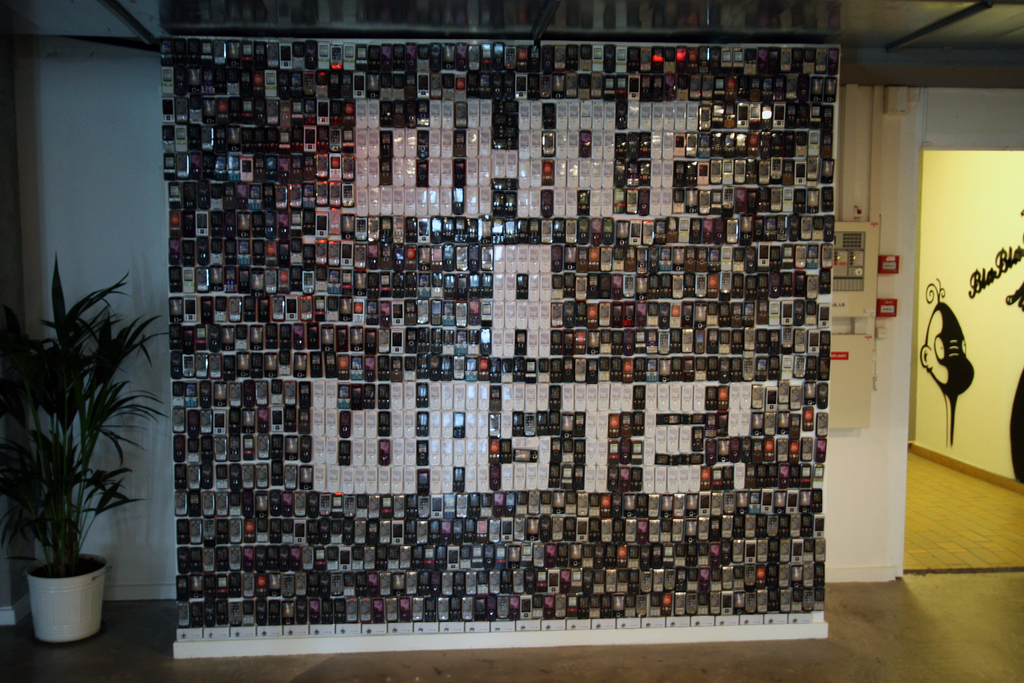Explain the visual content of the image in great detail. The image features an art installation within an indoor space, likely a gallery. This creative piece consists of a grid-like arrangement of countless small black and white photos that together create a striking mosaic. The individual photos seem varied, each potentially holding its own story or historical value. Collectively, they form the silhouette of a majestic bird in mid-flight, with its wings spanned wide. The strategic placement of certain images, varying in lighter and darker shades, provides the illusion of depth and movement within the bird's figure. On the left, there's a potted plant, introducing a natural element to the scene and offering a contrast to the mechanical precision of the photo mosaic. A sign is present in the background, possibly offering information about the exhibit, inviting viewers to learn more or reflect on the piece's message. The choice to depict a bird using a medium that captures moments in time might suggest themes of freedom, the passage of time, or the interplay between individuality and unity. 